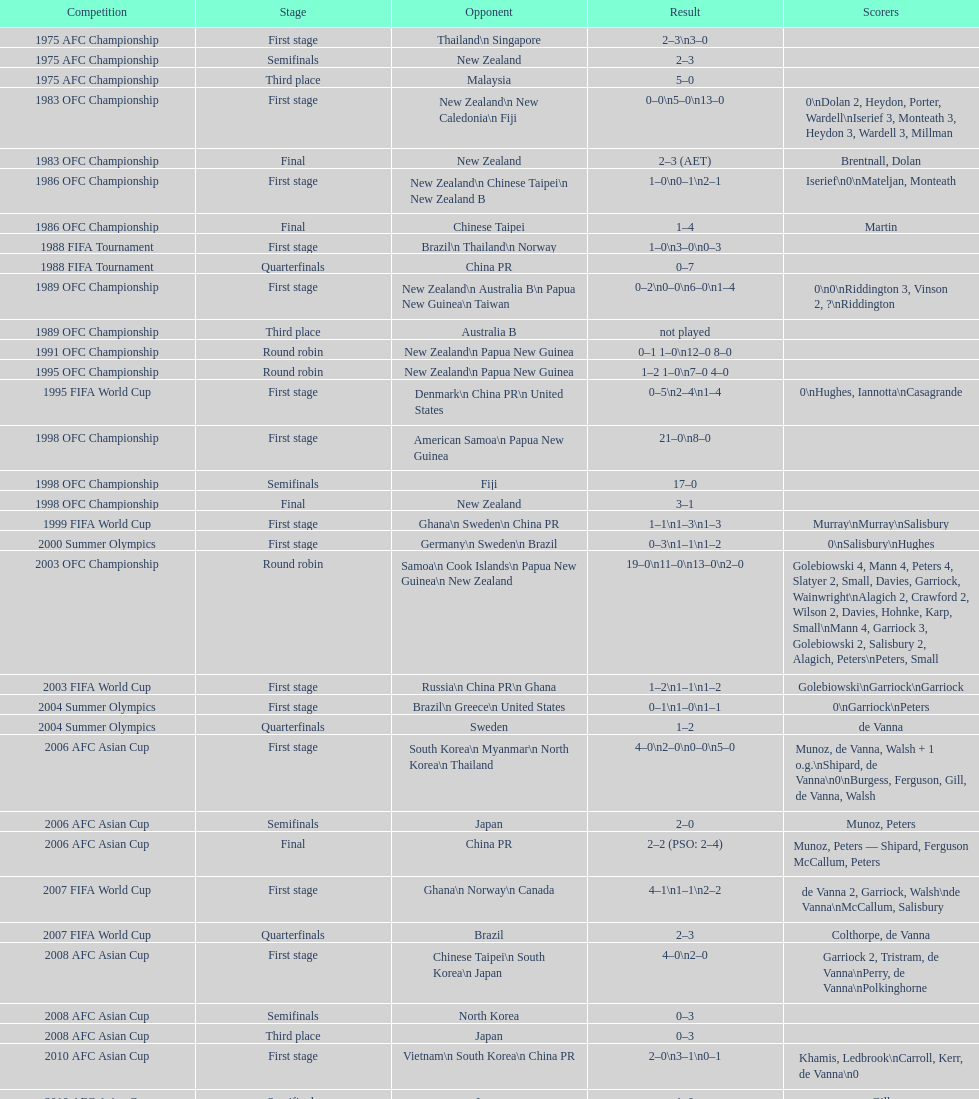Parse the full table. {'header': ['Competition', 'Stage', 'Opponent', 'Result', 'Scorers'], 'rows': [['1975 AFC Championship', 'First stage', 'Thailand\\n\xa0Singapore', '2–3\\n3–0', ''], ['1975 AFC Championship', 'Semifinals', 'New Zealand', '2–3', ''], ['1975 AFC Championship', 'Third place', 'Malaysia', '5–0', ''], ['1983 OFC Championship', 'First stage', 'New Zealand\\n\xa0New Caledonia\\n\xa0Fiji', '0–0\\n5–0\\n13–0', '0\\nDolan 2, Heydon, Porter, Wardell\\nIserief 3, Monteath 3, Heydon 3, Wardell 3, Millman'], ['1983 OFC Championship', 'Final', 'New Zealand', '2–3 (AET)', 'Brentnall, Dolan'], ['1986 OFC Championship', 'First stage', 'New Zealand\\n\xa0Chinese Taipei\\n New Zealand B', '1–0\\n0–1\\n2–1', 'Iserief\\n0\\nMateljan, Monteath'], ['1986 OFC Championship', 'Final', 'Chinese Taipei', '1–4', 'Martin'], ['1988 FIFA Tournament', 'First stage', 'Brazil\\n\xa0Thailand\\n\xa0Norway', '1–0\\n3–0\\n0–3', ''], ['1988 FIFA Tournament', 'Quarterfinals', 'China PR', '0–7', ''], ['1989 OFC Championship', 'First stage', 'New Zealand\\n Australia B\\n\xa0Papua New Guinea\\n\xa0Taiwan', '0–2\\n0–0\\n6–0\\n1–4', '0\\n0\\nRiddington 3, Vinson 2,\xa0?\\nRiddington'], ['1989 OFC Championship', 'Third place', 'Australia B', 'not played', ''], ['1991 OFC Championship', 'Round robin', 'New Zealand\\n\xa0Papua New Guinea', '0–1 1–0\\n12–0 8–0', ''], ['1995 OFC Championship', 'Round robin', 'New Zealand\\n\xa0Papua New Guinea', '1–2 1–0\\n7–0 4–0', ''], ['1995 FIFA World Cup', 'First stage', 'Denmark\\n\xa0China PR\\n\xa0United States', '0–5\\n2–4\\n1–4', '0\\nHughes, Iannotta\\nCasagrande'], ['1998 OFC Championship', 'First stage', 'American Samoa\\n\xa0Papua New Guinea', '21–0\\n8–0', ''], ['1998 OFC Championship', 'Semifinals', 'Fiji', '17–0', ''], ['1998 OFC Championship', 'Final', 'New Zealand', '3–1', ''], ['1999 FIFA World Cup', 'First stage', 'Ghana\\n\xa0Sweden\\n\xa0China PR', '1–1\\n1–3\\n1–3', 'Murray\\nMurray\\nSalisbury'], ['2000 Summer Olympics', 'First stage', 'Germany\\n\xa0Sweden\\n\xa0Brazil', '0–3\\n1–1\\n1–2', '0\\nSalisbury\\nHughes'], ['2003 OFC Championship', 'Round robin', 'Samoa\\n\xa0Cook Islands\\n\xa0Papua New Guinea\\n\xa0New Zealand', '19–0\\n11–0\\n13–0\\n2–0', 'Golebiowski 4, Mann 4, Peters 4, Slatyer 2, Small, Davies, Garriock, Wainwright\\nAlagich 2, Crawford 2, Wilson 2, Davies, Hohnke, Karp, Small\\nMann 4, Garriock 3, Golebiowski 2, Salisbury 2, Alagich, Peters\\nPeters, Small'], ['2003 FIFA World Cup', 'First stage', 'Russia\\n\xa0China PR\\n\xa0Ghana', '1–2\\n1–1\\n1–2', 'Golebiowski\\nGarriock\\nGarriock'], ['2004 Summer Olympics', 'First stage', 'Brazil\\n\xa0Greece\\n\xa0United States', '0–1\\n1–0\\n1–1', '0\\nGarriock\\nPeters'], ['2004 Summer Olympics', 'Quarterfinals', 'Sweden', '1–2', 'de Vanna'], ['2006 AFC Asian Cup', 'First stage', 'South Korea\\n\xa0Myanmar\\n\xa0North Korea\\n\xa0Thailand', '4–0\\n2–0\\n0–0\\n5–0', 'Munoz, de Vanna, Walsh + 1 o.g.\\nShipard, de Vanna\\n0\\nBurgess, Ferguson, Gill, de Vanna, Walsh'], ['2006 AFC Asian Cup', 'Semifinals', 'Japan', '2–0', 'Munoz, Peters'], ['2006 AFC Asian Cup', 'Final', 'China PR', '2–2 (PSO: 2–4)', 'Munoz, Peters — Shipard, Ferguson McCallum, Peters'], ['2007 FIFA World Cup', 'First stage', 'Ghana\\n\xa0Norway\\n\xa0Canada', '4–1\\n1–1\\n2–2', 'de Vanna 2, Garriock, Walsh\\nde Vanna\\nMcCallum, Salisbury'], ['2007 FIFA World Cup', 'Quarterfinals', 'Brazil', '2–3', 'Colthorpe, de Vanna'], ['2008 AFC Asian Cup', 'First stage', 'Chinese Taipei\\n\xa0South Korea\\n\xa0Japan', '4–0\\n2–0', 'Garriock 2, Tristram, de Vanna\\nPerry, de Vanna\\nPolkinghorne'], ['2008 AFC Asian Cup', 'Semifinals', 'North Korea', '0–3', ''], ['2008 AFC Asian Cup', 'Third place', 'Japan', '0–3', ''], ['2010 AFC Asian Cup', 'First stage', 'Vietnam\\n\xa0South Korea\\n\xa0China PR', '2–0\\n3–1\\n0–1', 'Khamis, Ledbrook\\nCarroll, Kerr, de Vanna\\n0'], ['2010 AFC Asian Cup', 'Semifinals', 'Japan', '1–0', 'Gill'], ['2010 AFC Asian Cup', 'Final', 'North Korea', '1–1 (PSO: 5–4)', 'Kerr — PSO: Shipard, Ledbrook, Gill, Garriock, Simon'], ['2011 FIFA World Cup', 'First stage', 'Brazil\\n\xa0Equatorial Guinea\\n\xa0Norway', '0–1\\n3–2\\n2–1', '0\\nvan Egmond, Khamis, de Vanna\\nSimon 2'], ['2011 FIFA World Cup', 'Quarterfinals', 'Sweden', '1–3', 'Perry'], ['2012 Summer Olympics\\nAFC qualification', 'Final round', 'North Korea\\n\xa0Thailand\\n\xa0Japan\\n\xa0China PR\\n\xa0South Korea', '0–1\\n5–1\\n0–1\\n1–0\\n2–1', '0\\nHeyman 2, Butt, van Egmond, Simon\\n0\\nvan Egmond\\nButt, de Vanna'], ['2014 AFC Asian Cup', 'First stage', 'Japan\\n\xa0Jordan\\n\xa0Vietnam', 'TBD\\nTBD\\nTBD', '']]} What is the variation in the number of goals scored at the 1999 fifa world cup compared to the 2000 summer olympics? 2. 